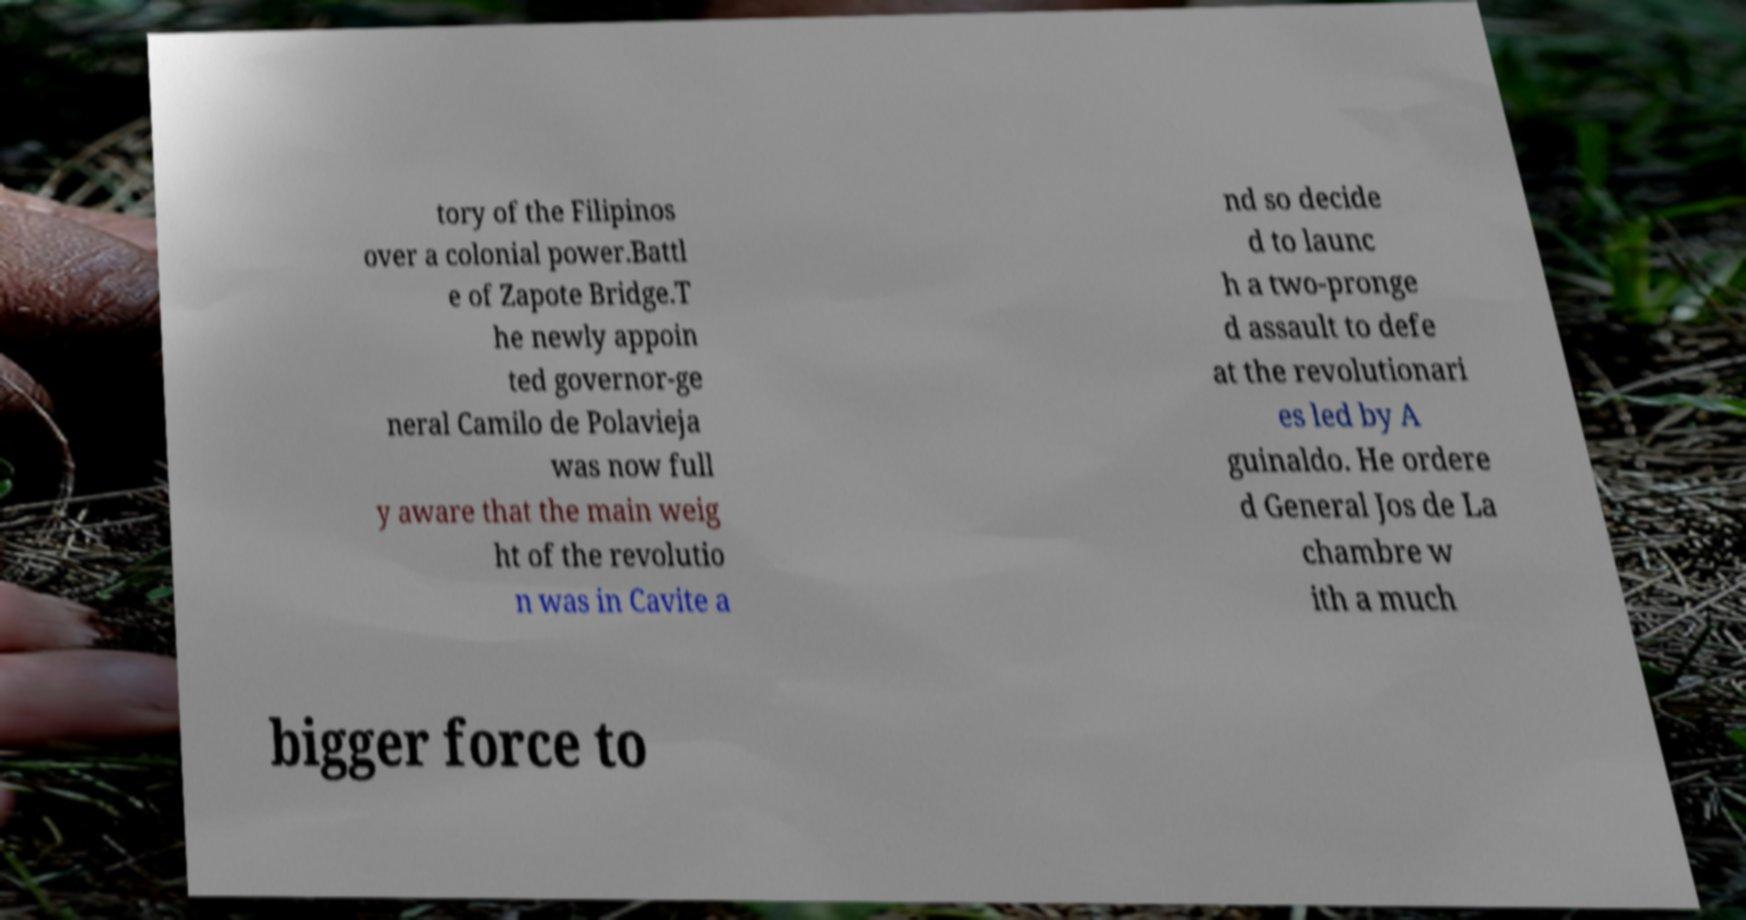For documentation purposes, I need the text within this image transcribed. Could you provide that? tory of the Filipinos over a colonial power.Battl e of Zapote Bridge.T he newly appoin ted governor-ge neral Camilo de Polavieja was now full y aware that the main weig ht of the revolutio n was in Cavite a nd so decide d to launc h a two-pronge d assault to defe at the revolutionari es led by A guinaldo. He ordere d General Jos de La chambre w ith a much bigger force to 